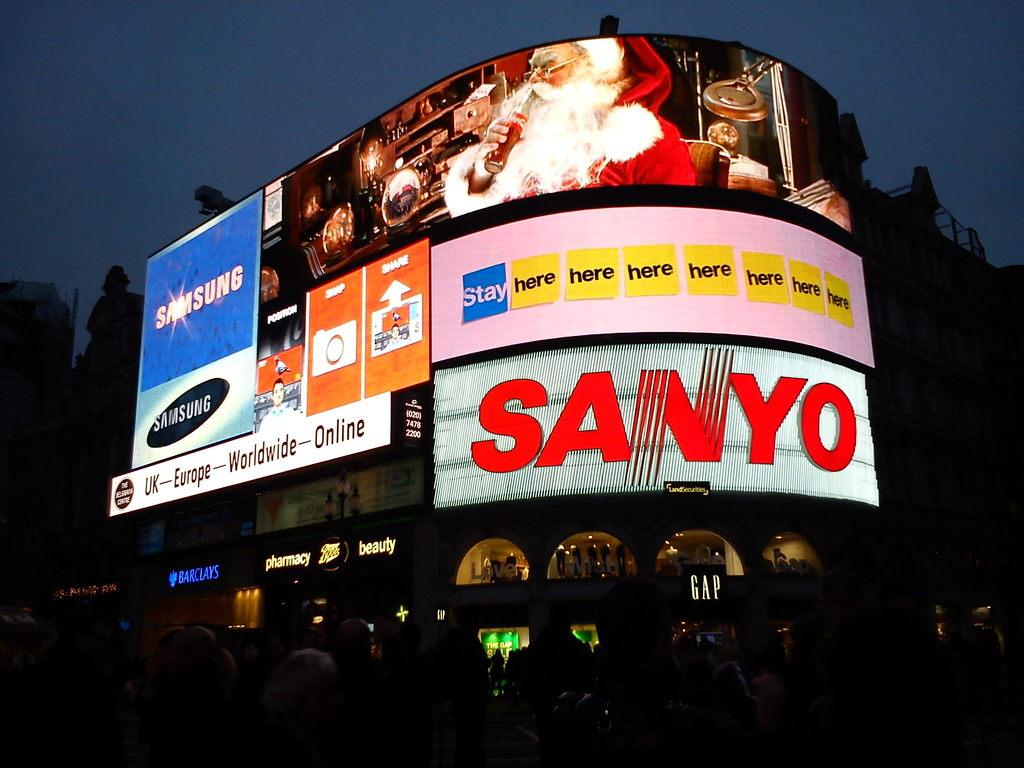<image>
Create a compact narrative representing the image presented. Large billboards for Coca Cola and Sanyo light up the street. 